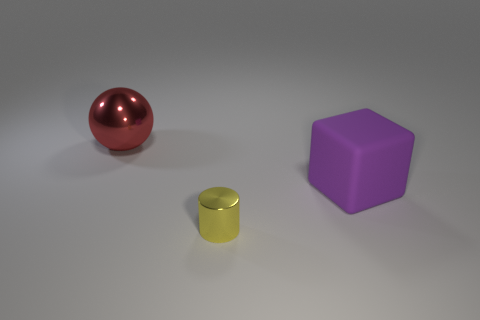Are there any other things that are the same size as the cylinder?
Your answer should be very brief. No. There is a red thing that is made of the same material as the yellow cylinder; what is its shape?
Make the answer very short. Sphere. There is a object that is both left of the matte block and in front of the red metallic sphere; what color is it?
Offer a very short reply. Yellow. Does the large object to the left of the yellow cylinder have the same material as the purple block?
Give a very brief answer. No. Is the number of tiny metal objects that are behind the purple rubber cube less than the number of purple rubber cylinders?
Provide a succinct answer. No. Are there any tiny yellow things that have the same material as the big red ball?
Provide a short and direct response. Yes. Do the matte cube and the shiny object that is right of the large red sphere have the same size?
Your answer should be compact. No. Is the big purple cube made of the same material as the ball?
Offer a terse response. No. There is a big red sphere; how many large spheres are on the left side of it?
Your answer should be very brief. 0. There is a object that is behind the tiny metal thing and in front of the sphere; what is its material?
Provide a short and direct response. Rubber. 